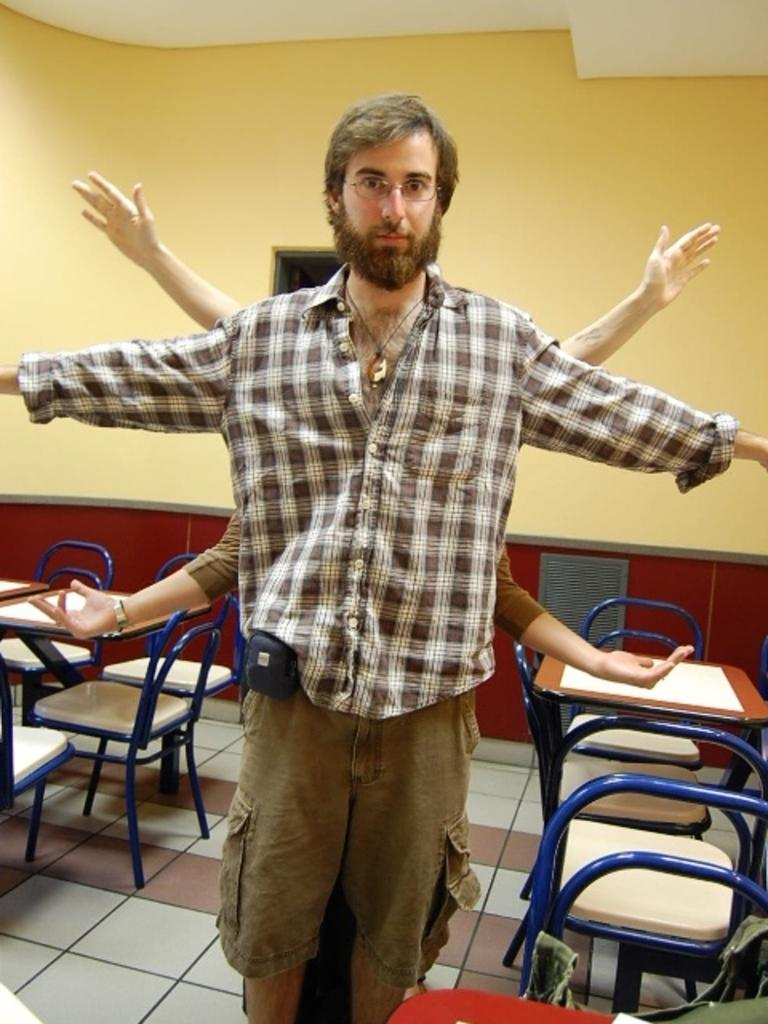What type of furniture is visible in the image? There are tables and chairs in the image. What is the person in the image doing? The person is stretching their arms. Can you describe the position of the person in the image? The person is standing or sitting while stretching their arms. What type of cheese is being used in the operation depicted in the image? There is no operation or cheese present in the image; it features tables, chairs, and a person stretching their arms. 